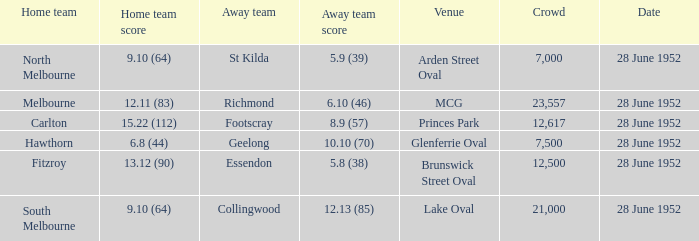Who is the visiting team when north melbourne has a home game? St Kilda. 